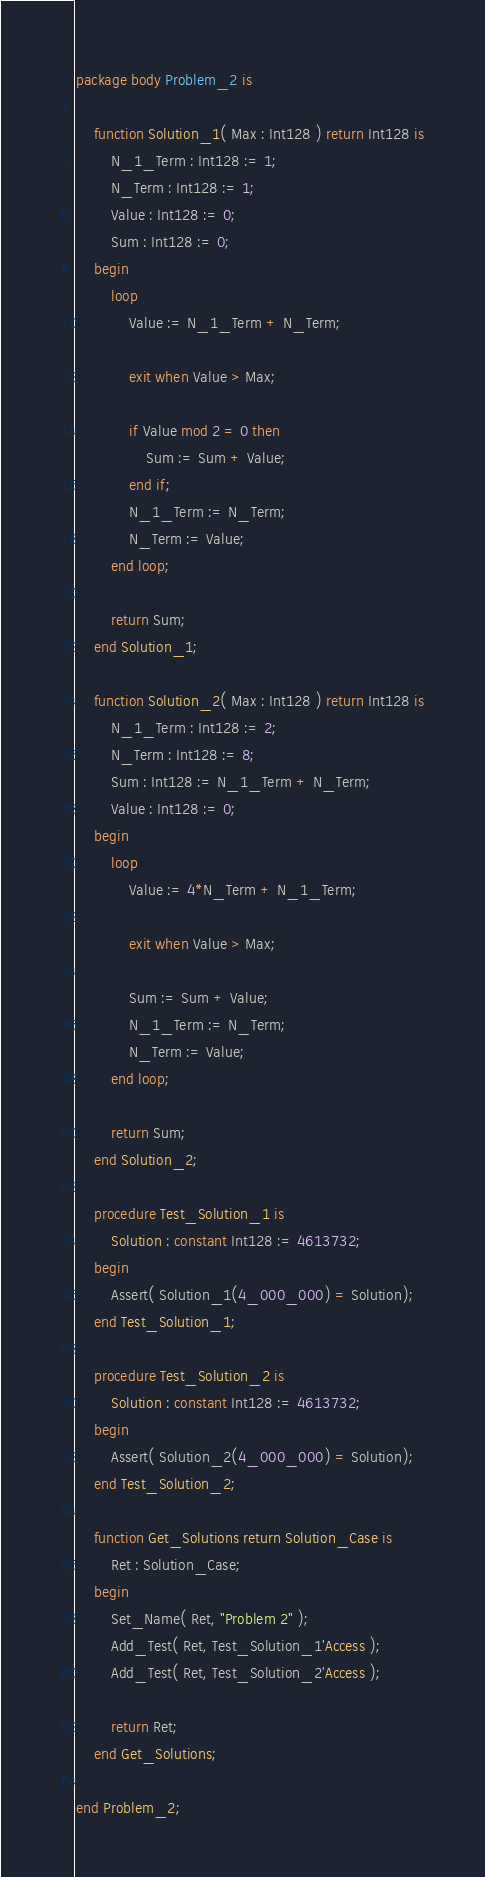Convert code to text. <code><loc_0><loc_0><loc_500><loc_500><_Ada_>package body Problem_2 is

    function Solution_1( Max : Int128 ) return Int128 is
        N_1_Term : Int128 := 1;
        N_Term : Int128 := 1;
        Value : Int128 := 0;
        Sum : Int128 := 0;
    begin
        loop
            Value := N_1_Term + N_Term;

            exit when Value > Max;

            if Value mod 2 = 0 then
                Sum := Sum + Value;
            end if;
            N_1_Term := N_Term;
            N_Term := Value;
        end loop;

        return Sum;
    end Solution_1;

    function Solution_2( Max : Int128 ) return Int128 is
        N_1_Term : Int128 := 2;
        N_Term : Int128 := 8;
        Sum : Int128 := N_1_Term + N_Term;
        Value : Int128 := 0;
    begin
        loop
            Value := 4*N_Term + N_1_Term;

            exit when Value > Max;

            Sum := Sum + Value;
            N_1_Term := N_Term;
            N_Term := Value;
        end loop;

        return Sum;
    end Solution_2;

    procedure Test_Solution_1 is
        Solution : constant Int128 := 4613732;
    begin
        Assert( Solution_1(4_000_000) = Solution);
    end Test_Solution_1;

    procedure Test_Solution_2 is
        Solution : constant Int128 := 4613732;
    begin
        Assert( Solution_2(4_000_000) = Solution);
    end Test_Solution_2;

    function Get_Solutions return Solution_Case is
        Ret : Solution_Case;
    begin
        Set_Name( Ret, "Problem 2" );
        Add_Test( Ret, Test_Solution_1'Access );
        Add_Test( Ret, Test_Solution_2'Access );

        return Ret;
    end Get_Solutions;

end Problem_2;
</code> 